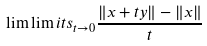<formula> <loc_0><loc_0><loc_500><loc_500>\lim \lim i t s _ { t \rightarrow 0 } \frac { \| x + t y \| - \| x \| } { t }</formula> 